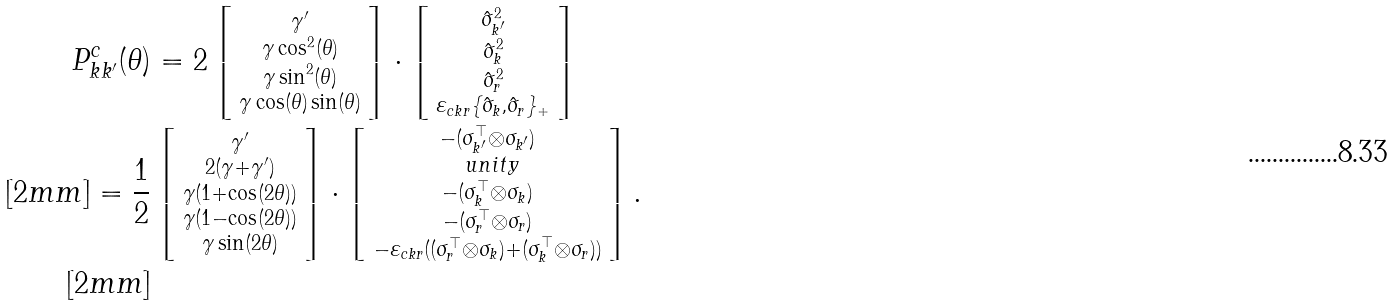Convert formula to latex. <formula><loc_0><loc_0><loc_500><loc_500>P ^ { c } _ { k k ^ { \prime } } ( \theta ) & = 2 \left [ \begin{smallmatrix} \gamma ^ { \prime } \\ \gamma \cos ^ { 2 } ( \theta ) \\ \gamma \sin ^ { 2 } ( \theta ) \\ \gamma \cos ( \theta ) \sin ( \theta ) \end{smallmatrix} \right ] \cdot \left [ \begin{smallmatrix} \hat { \sigma } ^ { 2 } _ { k ^ { \prime } } \\ \hat { \sigma } ^ { 2 } _ { k } \\ \hat { \sigma } _ { r } ^ { 2 } \\ \varepsilon _ { c k r } \{ \hat { \sigma } _ { k } , \hat { \sigma } _ { r } \} _ { + } \end{smallmatrix} \right ] \\ [ 2 m m ] = \frac { 1 } { 2 } & \left [ \begin{smallmatrix} \gamma ^ { \prime } \\ 2 ( \gamma + \gamma ^ { \prime } ) \\ \gamma ( 1 + \cos ( 2 \theta ) ) \\ \gamma ( 1 - \cos ( 2 \theta ) ) \\ \gamma \sin ( 2 \theta ) \end{smallmatrix} \right ] \cdot \left [ \begin{smallmatrix} - ( \sigma ^ { \top } _ { k ^ { \prime } } \otimes \sigma _ { k ^ { \prime } } ) \\ \ u n i t y \\ - ( \sigma ^ { \top } _ { k } \otimes \sigma _ { k } ) \\ - ( \sigma ^ { \top } _ { r } \otimes \sigma _ { r } ) \\ - \varepsilon _ { c k r } ( ( \sigma ^ { \top } _ { r } \otimes \sigma _ { k } ) + ( \sigma ^ { \top } _ { k } \otimes \sigma _ { r } ) ) \end{smallmatrix} \right ] . \\ [ 2 m m ]</formula> 